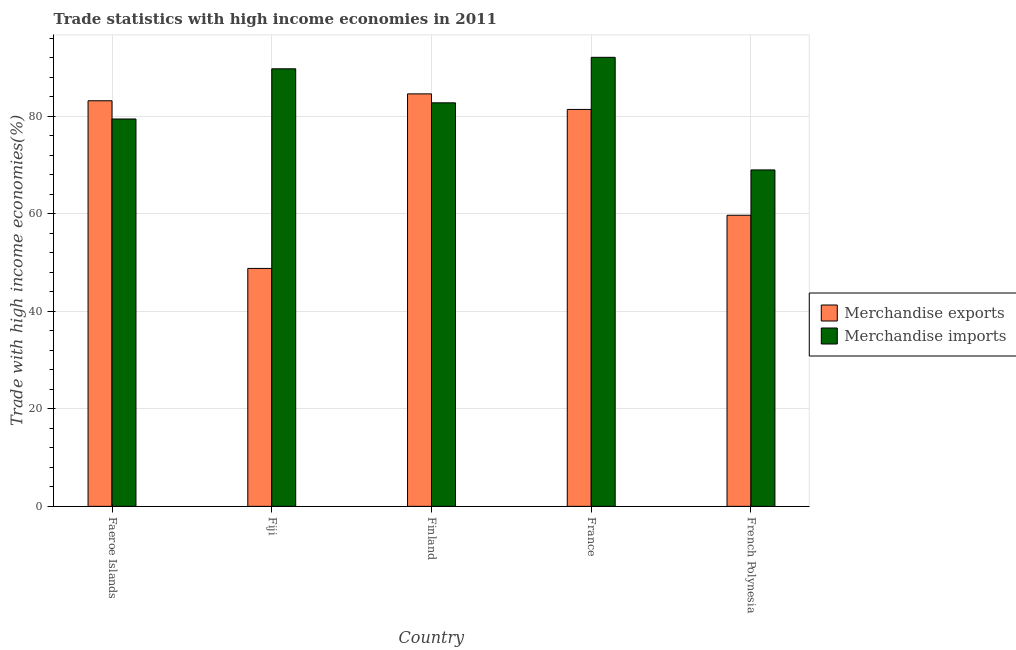How many different coloured bars are there?
Offer a terse response. 2. Are the number of bars on each tick of the X-axis equal?
Make the answer very short. Yes. How many bars are there on the 1st tick from the right?
Offer a terse response. 2. What is the merchandise exports in France?
Offer a very short reply. 81.38. Across all countries, what is the maximum merchandise exports?
Your answer should be compact. 84.57. Across all countries, what is the minimum merchandise exports?
Keep it short and to the point. 48.78. In which country was the merchandise imports maximum?
Offer a terse response. France. In which country was the merchandise exports minimum?
Make the answer very short. Fiji. What is the total merchandise exports in the graph?
Ensure brevity in your answer.  357.58. What is the difference between the merchandise imports in Fiji and that in France?
Provide a succinct answer. -2.35. What is the difference between the merchandise exports in Finland and the merchandise imports in France?
Give a very brief answer. -7.49. What is the average merchandise exports per country?
Give a very brief answer. 71.52. What is the difference between the merchandise exports and merchandise imports in Finland?
Offer a terse response. 1.84. In how many countries, is the merchandise imports greater than 20 %?
Make the answer very short. 5. What is the ratio of the merchandise exports in Faeroe Islands to that in French Polynesia?
Offer a terse response. 1.39. What is the difference between the highest and the second highest merchandise imports?
Provide a short and direct response. 2.35. What is the difference between the highest and the lowest merchandise imports?
Provide a succinct answer. 23.09. In how many countries, is the merchandise imports greater than the average merchandise imports taken over all countries?
Make the answer very short. 3. Is the sum of the merchandise imports in France and French Polynesia greater than the maximum merchandise exports across all countries?
Ensure brevity in your answer.  Yes. What does the 1st bar from the right in Finland represents?
Offer a very short reply. Merchandise imports. Are all the bars in the graph horizontal?
Your answer should be compact. No. What is the difference between two consecutive major ticks on the Y-axis?
Your answer should be compact. 20. Are the values on the major ticks of Y-axis written in scientific E-notation?
Offer a terse response. No. Where does the legend appear in the graph?
Make the answer very short. Center right. What is the title of the graph?
Your answer should be very brief. Trade statistics with high income economies in 2011. What is the label or title of the X-axis?
Your answer should be compact. Country. What is the label or title of the Y-axis?
Provide a succinct answer. Trade with high income economies(%). What is the Trade with high income economies(%) of Merchandise exports in Faeroe Islands?
Your response must be concise. 83.16. What is the Trade with high income economies(%) in Merchandise imports in Faeroe Islands?
Your response must be concise. 79.42. What is the Trade with high income economies(%) of Merchandise exports in Fiji?
Your answer should be compact. 48.78. What is the Trade with high income economies(%) of Merchandise imports in Fiji?
Provide a succinct answer. 89.71. What is the Trade with high income economies(%) of Merchandise exports in Finland?
Your response must be concise. 84.57. What is the Trade with high income economies(%) in Merchandise imports in Finland?
Your response must be concise. 82.74. What is the Trade with high income economies(%) in Merchandise exports in France?
Keep it short and to the point. 81.38. What is the Trade with high income economies(%) in Merchandise imports in France?
Make the answer very short. 92.06. What is the Trade with high income economies(%) in Merchandise exports in French Polynesia?
Keep it short and to the point. 59.68. What is the Trade with high income economies(%) of Merchandise imports in French Polynesia?
Offer a very short reply. 68.98. Across all countries, what is the maximum Trade with high income economies(%) in Merchandise exports?
Your response must be concise. 84.57. Across all countries, what is the maximum Trade with high income economies(%) of Merchandise imports?
Provide a succinct answer. 92.06. Across all countries, what is the minimum Trade with high income economies(%) in Merchandise exports?
Your response must be concise. 48.78. Across all countries, what is the minimum Trade with high income economies(%) in Merchandise imports?
Your answer should be compact. 68.98. What is the total Trade with high income economies(%) of Merchandise exports in the graph?
Provide a short and direct response. 357.58. What is the total Trade with high income economies(%) in Merchandise imports in the graph?
Ensure brevity in your answer.  412.91. What is the difference between the Trade with high income economies(%) in Merchandise exports in Faeroe Islands and that in Fiji?
Ensure brevity in your answer.  34.38. What is the difference between the Trade with high income economies(%) in Merchandise imports in Faeroe Islands and that in Fiji?
Make the answer very short. -10.29. What is the difference between the Trade with high income economies(%) in Merchandise exports in Faeroe Islands and that in Finland?
Ensure brevity in your answer.  -1.41. What is the difference between the Trade with high income economies(%) of Merchandise imports in Faeroe Islands and that in Finland?
Offer a very short reply. -3.31. What is the difference between the Trade with high income economies(%) in Merchandise exports in Faeroe Islands and that in France?
Offer a very short reply. 1.78. What is the difference between the Trade with high income economies(%) in Merchandise imports in Faeroe Islands and that in France?
Your answer should be very brief. -12.64. What is the difference between the Trade with high income economies(%) of Merchandise exports in Faeroe Islands and that in French Polynesia?
Keep it short and to the point. 23.48. What is the difference between the Trade with high income economies(%) of Merchandise imports in Faeroe Islands and that in French Polynesia?
Your response must be concise. 10.44. What is the difference between the Trade with high income economies(%) in Merchandise exports in Fiji and that in Finland?
Your response must be concise. -35.79. What is the difference between the Trade with high income economies(%) of Merchandise imports in Fiji and that in Finland?
Provide a succinct answer. 6.97. What is the difference between the Trade with high income economies(%) in Merchandise exports in Fiji and that in France?
Provide a short and direct response. -32.6. What is the difference between the Trade with high income economies(%) in Merchandise imports in Fiji and that in France?
Your answer should be compact. -2.35. What is the difference between the Trade with high income economies(%) of Merchandise imports in Fiji and that in French Polynesia?
Provide a succinct answer. 20.73. What is the difference between the Trade with high income economies(%) of Merchandise exports in Finland and that in France?
Make the answer very short. 3.19. What is the difference between the Trade with high income economies(%) in Merchandise imports in Finland and that in France?
Your answer should be compact. -9.33. What is the difference between the Trade with high income economies(%) in Merchandise exports in Finland and that in French Polynesia?
Provide a short and direct response. 24.89. What is the difference between the Trade with high income economies(%) in Merchandise imports in Finland and that in French Polynesia?
Offer a terse response. 13.76. What is the difference between the Trade with high income economies(%) of Merchandise exports in France and that in French Polynesia?
Your answer should be compact. 21.7. What is the difference between the Trade with high income economies(%) in Merchandise imports in France and that in French Polynesia?
Make the answer very short. 23.09. What is the difference between the Trade with high income economies(%) of Merchandise exports in Faeroe Islands and the Trade with high income economies(%) of Merchandise imports in Fiji?
Provide a succinct answer. -6.55. What is the difference between the Trade with high income economies(%) of Merchandise exports in Faeroe Islands and the Trade with high income economies(%) of Merchandise imports in Finland?
Make the answer very short. 0.42. What is the difference between the Trade with high income economies(%) of Merchandise exports in Faeroe Islands and the Trade with high income economies(%) of Merchandise imports in France?
Your answer should be very brief. -8.91. What is the difference between the Trade with high income economies(%) in Merchandise exports in Faeroe Islands and the Trade with high income economies(%) in Merchandise imports in French Polynesia?
Provide a succinct answer. 14.18. What is the difference between the Trade with high income economies(%) of Merchandise exports in Fiji and the Trade with high income economies(%) of Merchandise imports in Finland?
Your response must be concise. -33.95. What is the difference between the Trade with high income economies(%) in Merchandise exports in Fiji and the Trade with high income economies(%) in Merchandise imports in France?
Ensure brevity in your answer.  -43.28. What is the difference between the Trade with high income economies(%) in Merchandise exports in Fiji and the Trade with high income economies(%) in Merchandise imports in French Polynesia?
Your response must be concise. -20.19. What is the difference between the Trade with high income economies(%) in Merchandise exports in Finland and the Trade with high income economies(%) in Merchandise imports in France?
Your answer should be compact. -7.49. What is the difference between the Trade with high income economies(%) of Merchandise exports in Finland and the Trade with high income economies(%) of Merchandise imports in French Polynesia?
Your answer should be compact. 15.6. What is the difference between the Trade with high income economies(%) in Merchandise exports in France and the Trade with high income economies(%) in Merchandise imports in French Polynesia?
Offer a terse response. 12.4. What is the average Trade with high income economies(%) in Merchandise exports per country?
Offer a very short reply. 71.52. What is the average Trade with high income economies(%) in Merchandise imports per country?
Your response must be concise. 82.58. What is the difference between the Trade with high income economies(%) of Merchandise exports and Trade with high income economies(%) of Merchandise imports in Faeroe Islands?
Keep it short and to the point. 3.74. What is the difference between the Trade with high income economies(%) of Merchandise exports and Trade with high income economies(%) of Merchandise imports in Fiji?
Ensure brevity in your answer.  -40.93. What is the difference between the Trade with high income economies(%) in Merchandise exports and Trade with high income economies(%) in Merchandise imports in Finland?
Your response must be concise. 1.84. What is the difference between the Trade with high income economies(%) of Merchandise exports and Trade with high income economies(%) of Merchandise imports in France?
Your response must be concise. -10.68. What is the difference between the Trade with high income economies(%) in Merchandise exports and Trade with high income economies(%) in Merchandise imports in French Polynesia?
Give a very brief answer. -9.29. What is the ratio of the Trade with high income economies(%) in Merchandise exports in Faeroe Islands to that in Fiji?
Keep it short and to the point. 1.7. What is the ratio of the Trade with high income economies(%) of Merchandise imports in Faeroe Islands to that in Fiji?
Your response must be concise. 0.89. What is the ratio of the Trade with high income economies(%) of Merchandise exports in Faeroe Islands to that in Finland?
Your answer should be very brief. 0.98. What is the ratio of the Trade with high income economies(%) in Merchandise imports in Faeroe Islands to that in Finland?
Provide a short and direct response. 0.96. What is the ratio of the Trade with high income economies(%) of Merchandise exports in Faeroe Islands to that in France?
Make the answer very short. 1.02. What is the ratio of the Trade with high income economies(%) of Merchandise imports in Faeroe Islands to that in France?
Make the answer very short. 0.86. What is the ratio of the Trade with high income economies(%) in Merchandise exports in Faeroe Islands to that in French Polynesia?
Provide a short and direct response. 1.39. What is the ratio of the Trade with high income economies(%) of Merchandise imports in Faeroe Islands to that in French Polynesia?
Your answer should be very brief. 1.15. What is the ratio of the Trade with high income economies(%) of Merchandise exports in Fiji to that in Finland?
Your response must be concise. 0.58. What is the ratio of the Trade with high income economies(%) in Merchandise imports in Fiji to that in Finland?
Provide a succinct answer. 1.08. What is the ratio of the Trade with high income economies(%) in Merchandise exports in Fiji to that in France?
Offer a very short reply. 0.6. What is the ratio of the Trade with high income economies(%) of Merchandise imports in Fiji to that in France?
Your answer should be very brief. 0.97. What is the ratio of the Trade with high income economies(%) of Merchandise exports in Fiji to that in French Polynesia?
Your answer should be compact. 0.82. What is the ratio of the Trade with high income economies(%) of Merchandise imports in Fiji to that in French Polynesia?
Make the answer very short. 1.3. What is the ratio of the Trade with high income economies(%) in Merchandise exports in Finland to that in France?
Provide a short and direct response. 1.04. What is the ratio of the Trade with high income economies(%) of Merchandise imports in Finland to that in France?
Keep it short and to the point. 0.9. What is the ratio of the Trade with high income economies(%) in Merchandise exports in Finland to that in French Polynesia?
Offer a terse response. 1.42. What is the ratio of the Trade with high income economies(%) in Merchandise imports in Finland to that in French Polynesia?
Your answer should be very brief. 1.2. What is the ratio of the Trade with high income economies(%) in Merchandise exports in France to that in French Polynesia?
Provide a short and direct response. 1.36. What is the ratio of the Trade with high income economies(%) in Merchandise imports in France to that in French Polynesia?
Make the answer very short. 1.33. What is the difference between the highest and the second highest Trade with high income economies(%) of Merchandise exports?
Make the answer very short. 1.41. What is the difference between the highest and the second highest Trade with high income economies(%) of Merchandise imports?
Ensure brevity in your answer.  2.35. What is the difference between the highest and the lowest Trade with high income economies(%) of Merchandise exports?
Your response must be concise. 35.79. What is the difference between the highest and the lowest Trade with high income economies(%) of Merchandise imports?
Provide a short and direct response. 23.09. 